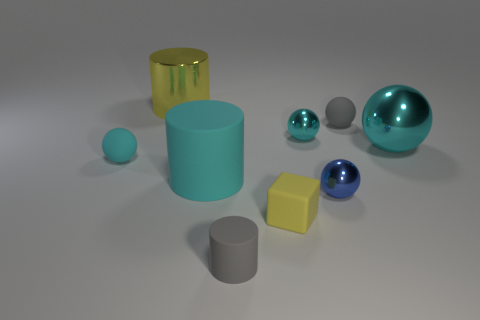Is the material of the large yellow object the same as the large cyan sphere?
Your response must be concise. Yes. There is a rubber cylinder in front of the blue metallic ball; what number of rubber spheres are on the left side of it?
Provide a short and direct response. 1. How many blue things are either metallic cylinders or big metal balls?
Provide a short and direct response. 0. There is a big metallic thing that is in front of the gray thing that is behind the cyan thing that is behind the big ball; what shape is it?
Provide a succinct answer. Sphere. What color is the matte block that is the same size as the gray matte cylinder?
Make the answer very short. Yellow. How many tiny gray objects have the same shape as the large matte object?
Your answer should be very brief. 1. Do the matte cube and the metallic object that is behind the gray ball have the same size?
Your response must be concise. No. The metal object left of the thing that is in front of the yellow rubber cube is what shape?
Ensure brevity in your answer.  Cylinder. Are there fewer small cyan metal spheres that are to the left of the tiny cyan metal sphere than tiny brown spheres?
Your answer should be compact. No. There is a big thing that is the same color as the large shiny ball; what shape is it?
Your answer should be compact. Cylinder. 